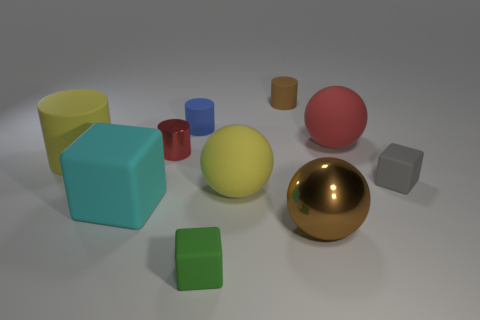How does the lighting in the scene affect the appearance of objects? The lighting in the scene appears to be coming from above, casting soft shadows beneath the objects. It highlights the shapes and textures, giving the shiny surfaces like the gold ball a reflective sheen that stands out against the more matte surfaces of the other objects. 